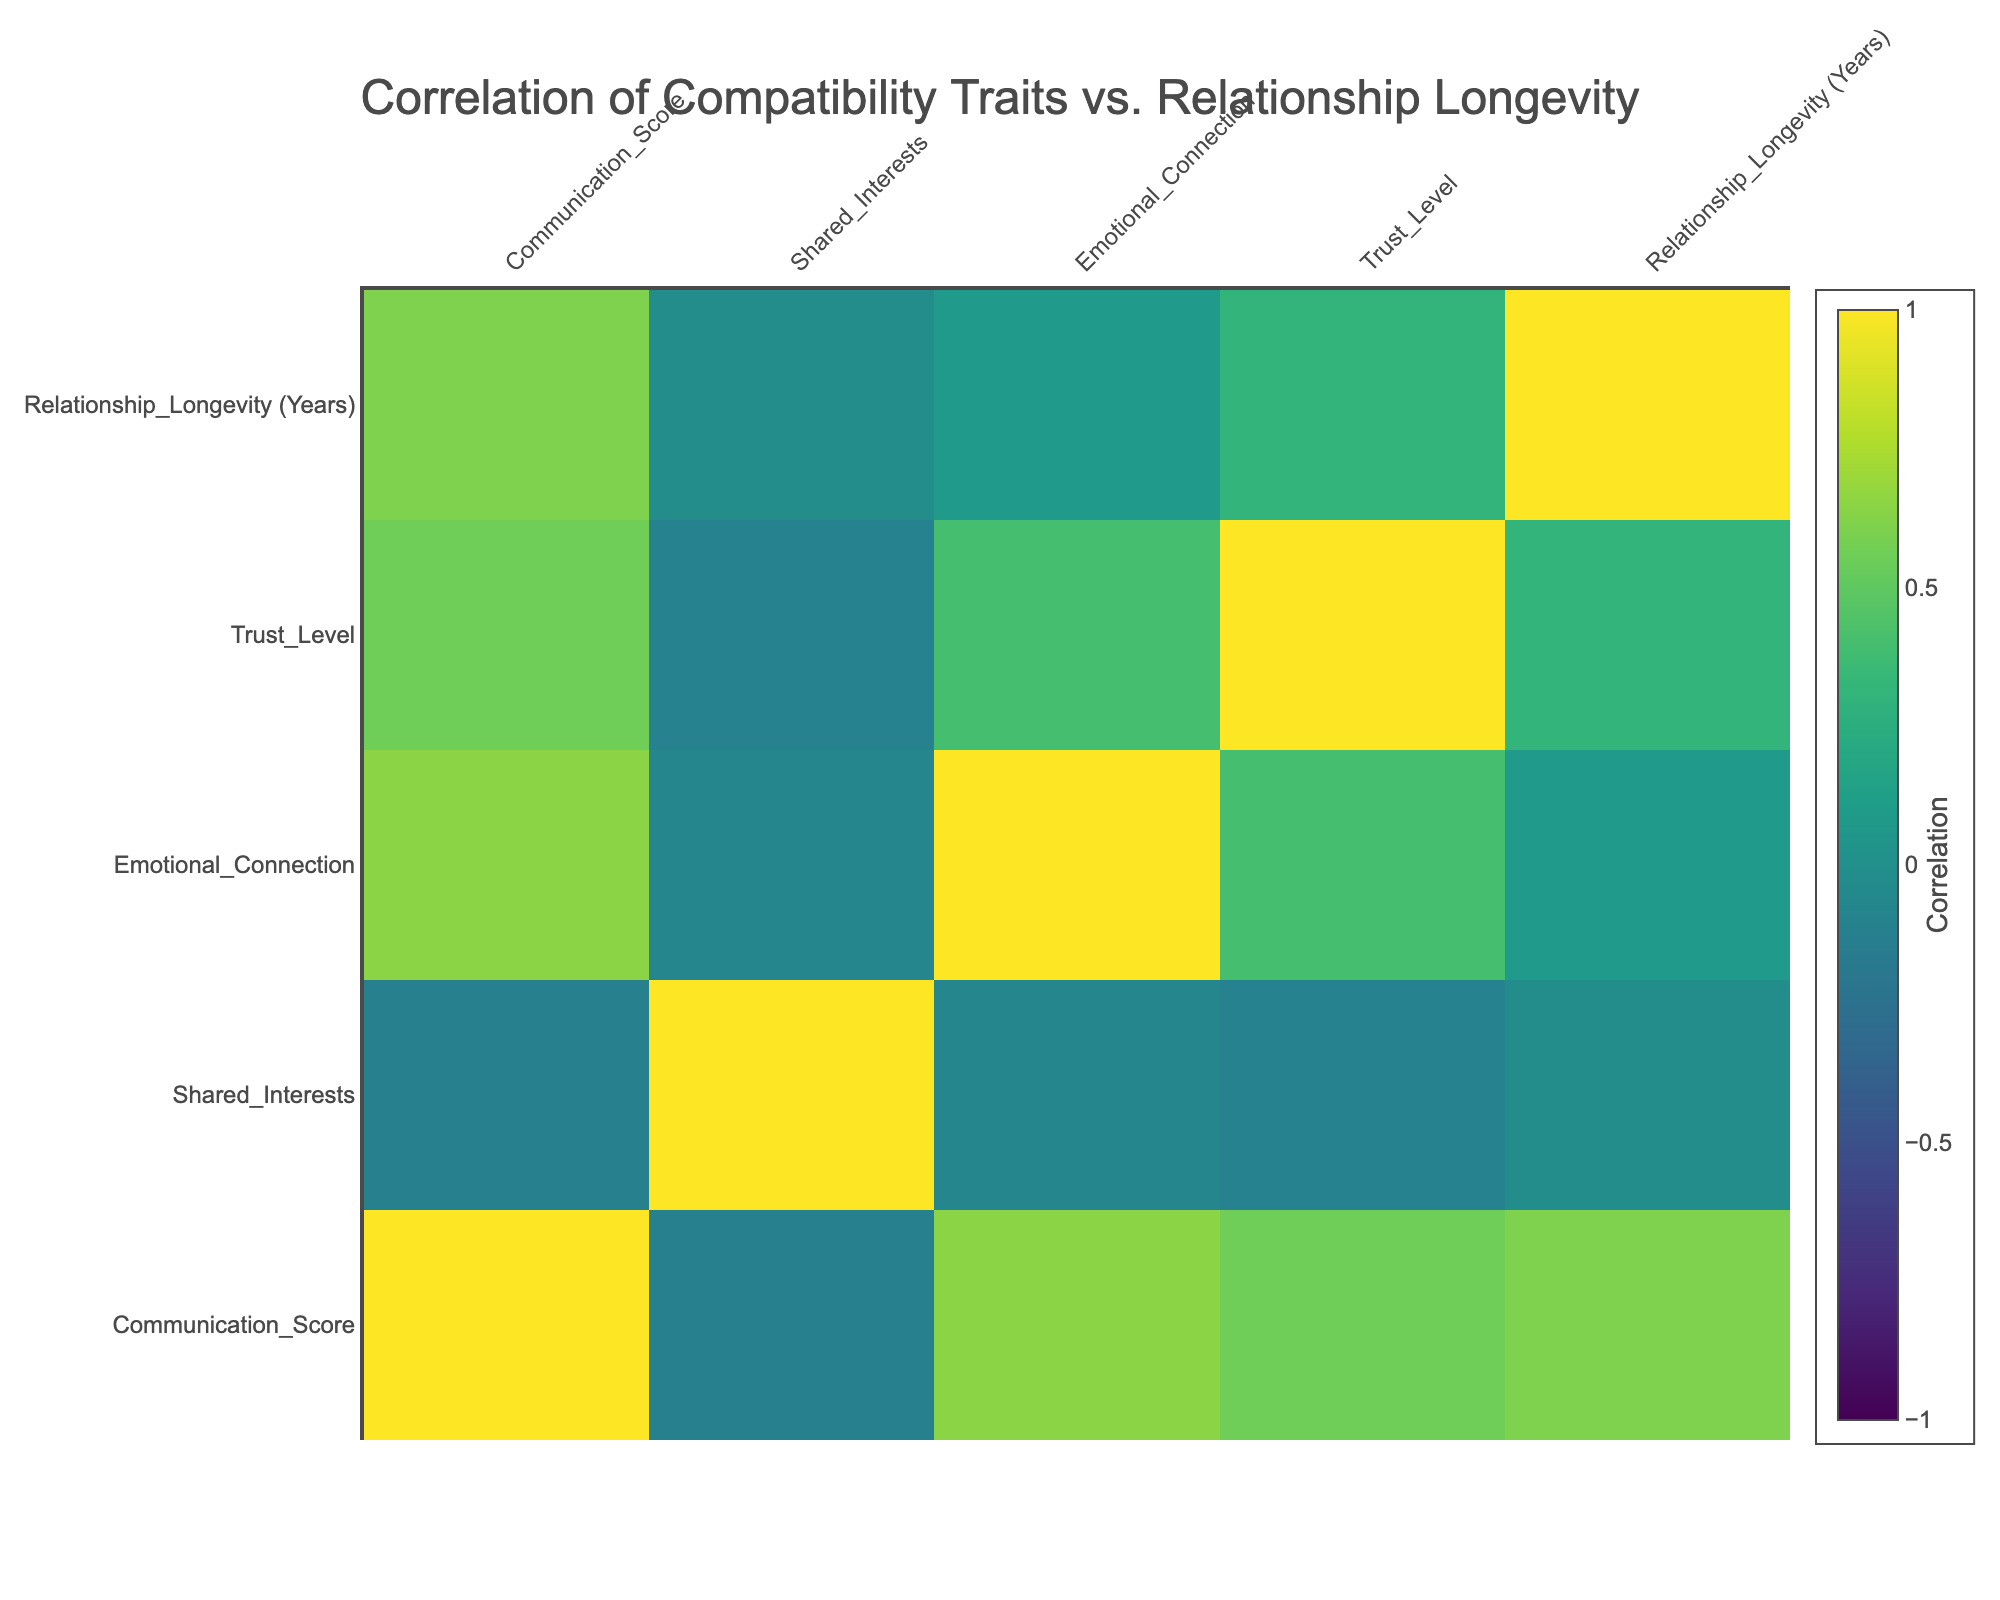What is the communication score for the trait of honesty? From the table, we can easily locate the row corresponding to honesty, which indicates a communication score of 8.
Answer: 8 Which compatibility trait has the highest trust level? By examining the trust level column, respect has the highest value at 10, indicating it is the trait with the highest trust level.
Answer: Respect What is the average relationship longevity for the traits of empathy and conflict resolution ability? The longevity values for empathy and conflict resolution ability are 5 and 4, respectively. To find the average, we sum these (5 + 4 = 9) and divide by 2, resulting in 9/2 = 4.5.
Answer: 4.5 Is there a correlation between shared interests and relationship longevity? We can refer to the correlation table: the correlation coefficient between shared interests and relationship longevity is 0.3. This indicates a mild positive correlation, answering the query affirmatively.
Answer: Yes What is the difference in emotional connection scores between the traits of affection and sense of humor? The emotional connection score for affection is 10, and for sense of humor, it is 8. The difference between these scores is 10 - 8 = 2.
Answer: 2 What is the minimum trust level among all compatibility traits? By inspecting the trust level column, we find that the minimum value is 7 (coming from intellectual compatibility), indicating this is the lowest trust level among the traits.
Answer: 7 Does respect have a higher communication score than values alignment? The communication score for respect is 10 and for values alignment, it is 9. Since 10 is greater than 9, we confirm that respect does indeed have a higher communication score.
Answer: Yes What is the total emotional connection score for traits that have a trust level greater than 8? We find the traits with trust levels greater than 8 are honesty (9), respect (10), and affection (10). Their respective emotional connection scores are 9, 10, and 10. Therefore, the total is 9 + 10 + 10 = 29.
Answer: 29 What is the average communication score across all compatibility traits listed? We sum all the communication scores: 8, 9, 7, 8, 10, 6, 9, 7, 9, and 8, which totals 81. Dividing this sum by the number of traits (10), we find the average communication score to be 81/10 = 8.1.
Answer: 8.1 